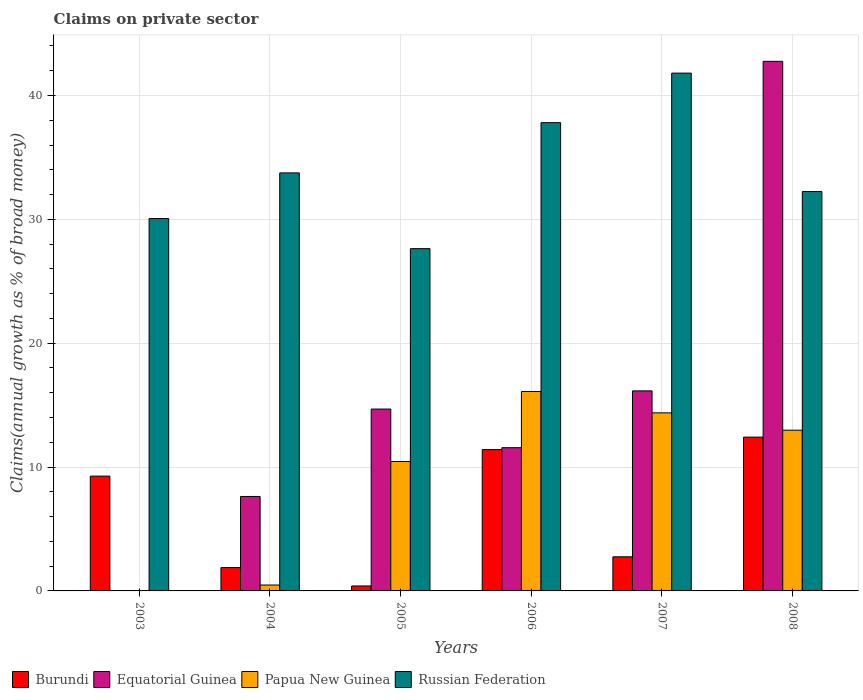How many different coloured bars are there?
Make the answer very short. 4. How many groups of bars are there?
Make the answer very short. 6. Are the number of bars on each tick of the X-axis equal?
Give a very brief answer. No. How many bars are there on the 2nd tick from the left?
Your answer should be very brief. 4. How many bars are there on the 6th tick from the right?
Your response must be concise. 2. What is the percentage of broad money claimed on private sector in Burundi in 2006?
Offer a very short reply. 11.41. Across all years, what is the maximum percentage of broad money claimed on private sector in Papua New Guinea?
Ensure brevity in your answer.  16.1. What is the total percentage of broad money claimed on private sector in Papua New Guinea in the graph?
Your response must be concise. 54.38. What is the difference between the percentage of broad money claimed on private sector in Equatorial Guinea in 2006 and that in 2008?
Keep it short and to the point. -31.19. What is the difference between the percentage of broad money claimed on private sector in Russian Federation in 2008 and the percentage of broad money claimed on private sector in Burundi in 2003?
Ensure brevity in your answer.  22.97. What is the average percentage of broad money claimed on private sector in Russian Federation per year?
Your response must be concise. 33.88. In the year 2007, what is the difference between the percentage of broad money claimed on private sector in Papua New Guinea and percentage of broad money claimed on private sector in Burundi?
Give a very brief answer. 11.62. What is the ratio of the percentage of broad money claimed on private sector in Russian Federation in 2006 to that in 2007?
Keep it short and to the point. 0.9. What is the difference between the highest and the second highest percentage of broad money claimed on private sector in Burundi?
Your answer should be compact. 1.01. What is the difference between the highest and the lowest percentage of broad money claimed on private sector in Papua New Guinea?
Your answer should be very brief. 16.1. In how many years, is the percentage of broad money claimed on private sector in Burundi greater than the average percentage of broad money claimed on private sector in Burundi taken over all years?
Your answer should be very brief. 3. Is it the case that in every year, the sum of the percentage of broad money claimed on private sector in Equatorial Guinea and percentage of broad money claimed on private sector in Papua New Guinea is greater than the percentage of broad money claimed on private sector in Burundi?
Give a very brief answer. No. How many bars are there?
Make the answer very short. 22. How many years are there in the graph?
Provide a succinct answer. 6. What is the difference between two consecutive major ticks on the Y-axis?
Make the answer very short. 10. Are the values on the major ticks of Y-axis written in scientific E-notation?
Provide a succinct answer. No. Does the graph contain any zero values?
Your answer should be very brief. Yes. Where does the legend appear in the graph?
Your response must be concise. Bottom left. How many legend labels are there?
Your answer should be compact. 4. How are the legend labels stacked?
Offer a terse response. Horizontal. What is the title of the graph?
Make the answer very short. Claims on private sector. What is the label or title of the Y-axis?
Offer a terse response. Claims(annual growth as % of broad money). What is the Claims(annual growth as % of broad money) of Burundi in 2003?
Provide a short and direct response. 9.27. What is the Claims(annual growth as % of broad money) of Equatorial Guinea in 2003?
Offer a terse response. 0. What is the Claims(annual growth as % of broad money) in Russian Federation in 2003?
Provide a succinct answer. 30.06. What is the Claims(annual growth as % of broad money) in Burundi in 2004?
Ensure brevity in your answer.  1.88. What is the Claims(annual growth as % of broad money) of Equatorial Guinea in 2004?
Your answer should be compact. 7.63. What is the Claims(annual growth as % of broad money) in Papua New Guinea in 2004?
Provide a short and direct response. 0.48. What is the Claims(annual growth as % of broad money) of Russian Federation in 2004?
Provide a succinct answer. 33.75. What is the Claims(annual growth as % of broad money) of Burundi in 2005?
Make the answer very short. 0.4. What is the Claims(annual growth as % of broad money) of Equatorial Guinea in 2005?
Your answer should be compact. 14.68. What is the Claims(annual growth as % of broad money) of Papua New Guinea in 2005?
Your response must be concise. 10.45. What is the Claims(annual growth as % of broad money) of Russian Federation in 2005?
Give a very brief answer. 27.63. What is the Claims(annual growth as % of broad money) of Burundi in 2006?
Provide a short and direct response. 11.41. What is the Claims(annual growth as % of broad money) of Equatorial Guinea in 2006?
Offer a terse response. 11.56. What is the Claims(annual growth as % of broad money) in Papua New Guinea in 2006?
Your answer should be very brief. 16.1. What is the Claims(annual growth as % of broad money) in Russian Federation in 2006?
Keep it short and to the point. 37.8. What is the Claims(annual growth as % of broad money) of Burundi in 2007?
Provide a short and direct response. 2.75. What is the Claims(annual growth as % of broad money) in Equatorial Guinea in 2007?
Keep it short and to the point. 16.15. What is the Claims(annual growth as % of broad money) of Papua New Guinea in 2007?
Make the answer very short. 14.38. What is the Claims(annual growth as % of broad money) of Russian Federation in 2007?
Your response must be concise. 41.8. What is the Claims(annual growth as % of broad money) in Burundi in 2008?
Provide a short and direct response. 12.42. What is the Claims(annual growth as % of broad money) in Equatorial Guinea in 2008?
Provide a short and direct response. 42.75. What is the Claims(annual growth as % of broad money) in Papua New Guinea in 2008?
Offer a terse response. 12.98. What is the Claims(annual growth as % of broad money) of Russian Federation in 2008?
Provide a short and direct response. 32.24. Across all years, what is the maximum Claims(annual growth as % of broad money) of Burundi?
Offer a terse response. 12.42. Across all years, what is the maximum Claims(annual growth as % of broad money) of Equatorial Guinea?
Make the answer very short. 42.75. Across all years, what is the maximum Claims(annual growth as % of broad money) of Papua New Guinea?
Your response must be concise. 16.1. Across all years, what is the maximum Claims(annual growth as % of broad money) of Russian Federation?
Keep it short and to the point. 41.8. Across all years, what is the minimum Claims(annual growth as % of broad money) in Burundi?
Provide a short and direct response. 0.4. Across all years, what is the minimum Claims(annual growth as % of broad money) of Equatorial Guinea?
Your response must be concise. 0. Across all years, what is the minimum Claims(annual growth as % of broad money) in Russian Federation?
Keep it short and to the point. 27.63. What is the total Claims(annual growth as % of broad money) in Burundi in the graph?
Your response must be concise. 38.13. What is the total Claims(annual growth as % of broad money) of Equatorial Guinea in the graph?
Your response must be concise. 92.78. What is the total Claims(annual growth as % of broad money) in Papua New Guinea in the graph?
Your answer should be very brief. 54.38. What is the total Claims(annual growth as % of broad money) in Russian Federation in the graph?
Provide a succinct answer. 203.29. What is the difference between the Claims(annual growth as % of broad money) of Burundi in 2003 and that in 2004?
Your response must be concise. 7.38. What is the difference between the Claims(annual growth as % of broad money) in Russian Federation in 2003 and that in 2004?
Your response must be concise. -3.69. What is the difference between the Claims(annual growth as % of broad money) in Burundi in 2003 and that in 2005?
Offer a very short reply. 8.87. What is the difference between the Claims(annual growth as % of broad money) of Russian Federation in 2003 and that in 2005?
Offer a terse response. 2.43. What is the difference between the Claims(annual growth as % of broad money) of Burundi in 2003 and that in 2006?
Ensure brevity in your answer.  -2.14. What is the difference between the Claims(annual growth as % of broad money) in Russian Federation in 2003 and that in 2006?
Your answer should be very brief. -7.74. What is the difference between the Claims(annual growth as % of broad money) in Burundi in 2003 and that in 2007?
Make the answer very short. 6.51. What is the difference between the Claims(annual growth as % of broad money) in Russian Federation in 2003 and that in 2007?
Offer a very short reply. -11.74. What is the difference between the Claims(annual growth as % of broad money) in Burundi in 2003 and that in 2008?
Your answer should be compact. -3.15. What is the difference between the Claims(annual growth as % of broad money) of Russian Federation in 2003 and that in 2008?
Your answer should be very brief. -2.18. What is the difference between the Claims(annual growth as % of broad money) of Burundi in 2004 and that in 2005?
Your answer should be very brief. 1.48. What is the difference between the Claims(annual growth as % of broad money) in Equatorial Guinea in 2004 and that in 2005?
Keep it short and to the point. -7.06. What is the difference between the Claims(annual growth as % of broad money) of Papua New Guinea in 2004 and that in 2005?
Keep it short and to the point. -9.98. What is the difference between the Claims(annual growth as % of broad money) in Russian Federation in 2004 and that in 2005?
Your response must be concise. 6.12. What is the difference between the Claims(annual growth as % of broad money) of Burundi in 2004 and that in 2006?
Ensure brevity in your answer.  -9.52. What is the difference between the Claims(annual growth as % of broad money) in Equatorial Guinea in 2004 and that in 2006?
Offer a very short reply. -3.94. What is the difference between the Claims(annual growth as % of broad money) of Papua New Guinea in 2004 and that in 2006?
Give a very brief answer. -15.62. What is the difference between the Claims(annual growth as % of broad money) in Russian Federation in 2004 and that in 2006?
Keep it short and to the point. -4.06. What is the difference between the Claims(annual growth as % of broad money) in Burundi in 2004 and that in 2007?
Give a very brief answer. -0.87. What is the difference between the Claims(annual growth as % of broad money) in Equatorial Guinea in 2004 and that in 2007?
Keep it short and to the point. -8.52. What is the difference between the Claims(annual growth as % of broad money) of Papua New Guinea in 2004 and that in 2007?
Provide a short and direct response. -13.9. What is the difference between the Claims(annual growth as % of broad money) of Russian Federation in 2004 and that in 2007?
Ensure brevity in your answer.  -8.06. What is the difference between the Claims(annual growth as % of broad money) of Burundi in 2004 and that in 2008?
Offer a terse response. -10.53. What is the difference between the Claims(annual growth as % of broad money) in Equatorial Guinea in 2004 and that in 2008?
Keep it short and to the point. -35.13. What is the difference between the Claims(annual growth as % of broad money) of Papua New Guinea in 2004 and that in 2008?
Your answer should be compact. -12.5. What is the difference between the Claims(annual growth as % of broad money) of Russian Federation in 2004 and that in 2008?
Provide a succinct answer. 1.51. What is the difference between the Claims(annual growth as % of broad money) in Burundi in 2005 and that in 2006?
Ensure brevity in your answer.  -11.01. What is the difference between the Claims(annual growth as % of broad money) in Equatorial Guinea in 2005 and that in 2006?
Provide a succinct answer. 3.12. What is the difference between the Claims(annual growth as % of broad money) in Papua New Guinea in 2005 and that in 2006?
Your response must be concise. -5.65. What is the difference between the Claims(annual growth as % of broad money) of Russian Federation in 2005 and that in 2006?
Provide a short and direct response. -10.17. What is the difference between the Claims(annual growth as % of broad money) of Burundi in 2005 and that in 2007?
Make the answer very short. -2.35. What is the difference between the Claims(annual growth as % of broad money) in Equatorial Guinea in 2005 and that in 2007?
Your answer should be compact. -1.47. What is the difference between the Claims(annual growth as % of broad money) of Papua New Guinea in 2005 and that in 2007?
Give a very brief answer. -3.93. What is the difference between the Claims(annual growth as % of broad money) in Russian Federation in 2005 and that in 2007?
Your answer should be compact. -14.17. What is the difference between the Claims(annual growth as % of broad money) of Burundi in 2005 and that in 2008?
Give a very brief answer. -12.02. What is the difference between the Claims(annual growth as % of broad money) of Equatorial Guinea in 2005 and that in 2008?
Your response must be concise. -28.07. What is the difference between the Claims(annual growth as % of broad money) of Papua New Guinea in 2005 and that in 2008?
Provide a succinct answer. -2.53. What is the difference between the Claims(annual growth as % of broad money) of Russian Federation in 2005 and that in 2008?
Provide a short and direct response. -4.61. What is the difference between the Claims(annual growth as % of broad money) of Burundi in 2006 and that in 2007?
Offer a terse response. 8.65. What is the difference between the Claims(annual growth as % of broad money) in Equatorial Guinea in 2006 and that in 2007?
Offer a terse response. -4.59. What is the difference between the Claims(annual growth as % of broad money) of Papua New Guinea in 2006 and that in 2007?
Your response must be concise. 1.72. What is the difference between the Claims(annual growth as % of broad money) in Russian Federation in 2006 and that in 2007?
Your response must be concise. -4. What is the difference between the Claims(annual growth as % of broad money) of Burundi in 2006 and that in 2008?
Ensure brevity in your answer.  -1.01. What is the difference between the Claims(annual growth as % of broad money) of Equatorial Guinea in 2006 and that in 2008?
Offer a very short reply. -31.19. What is the difference between the Claims(annual growth as % of broad money) in Papua New Guinea in 2006 and that in 2008?
Provide a short and direct response. 3.12. What is the difference between the Claims(annual growth as % of broad money) in Russian Federation in 2006 and that in 2008?
Provide a succinct answer. 5.56. What is the difference between the Claims(annual growth as % of broad money) in Burundi in 2007 and that in 2008?
Your answer should be very brief. -9.66. What is the difference between the Claims(annual growth as % of broad money) in Equatorial Guinea in 2007 and that in 2008?
Your response must be concise. -26.6. What is the difference between the Claims(annual growth as % of broad money) in Papua New Guinea in 2007 and that in 2008?
Make the answer very short. 1.4. What is the difference between the Claims(annual growth as % of broad money) in Russian Federation in 2007 and that in 2008?
Your response must be concise. 9.56. What is the difference between the Claims(annual growth as % of broad money) in Burundi in 2003 and the Claims(annual growth as % of broad money) in Equatorial Guinea in 2004?
Ensure brevity in your answer.  1.64. What is the difference between the Claims(annual growth as % of broad money) of Burundi in 2003 and the Claims(annual growth as % of broad money) of Papua New Guinea in 2004?
Offer a very short reply. 8.79. What is the difference between the Claims(annual growth as % of broad money) of Burundi in 2003 and the Claims(annual growth as % of broad money) of Russian Federation in 2004?
Provide a short and direct response. -24.48. What is the difference between the Claims(annual growth as % of broad money) of Burundi in 2003 and the Claims(annual growth as % of broad money) of Equatorial Guinea in 2005?
Ensure brevity in your answer.  -5.41. What is the difference between the Claims(annual growth as % of broad money) of Burundi in 2003 and the Claims(annual growth as % of broad money) of Papua New Guinea in 2005?
Provide a short and direct response. -1.18. What is the difference between the Claims(annual growth as % of broad money) in Burundi in 2003 and the Claims(annual growth as % of broad money) in Russian Federation in 2005?
Offer a terse response. -18.36. What is the difference between the Claims(annual growth as % of broad money) in Burundi in 2003 and the Claims(annual growth as % of broad money) in Equatorial Guinea in 2006?
Offer a very short reply. -2.3. What is the difference between the Claims(annual growth as % of broad money) of Burundi in 2003 and the Claims(annual growth as % of broad money) of Papua New Guinea in 2006?
Provide a short and direct response. -6.83. What is the difference between the Claims(annual growth as % of broad money) in Burundi in 2003 and the Claims(annual growth as % of broad money) in Russian Federation in 2006?
Ensure brevity in your answer.  -28.54. What is the difference between the Claims(annual growth as % of broad money) of Burundi in 2003 and the Claims(annual growth as % of broad money) of Equatorial Guinea in 2007?
Make the answer very short. -6.88. What is the difference between the Claims(annual growth as % of broad money) in Burundi in 2003 and the Claims(annual growth as % of broad money) in Papua New Guinea in 2007?
Your answer should be compact. -5.11. What is the difference between the Claims(annual growth as % of broad money) in Burundi in 2003 and the Claims(annual growth as % of broad money) in Russian Federation in 2007?
Make the answer very short. -32.54. What is the difference between the Claims(annual growth as % of broad money) of Burundi in 2003 and the Claims(annual growth as % of broad money) of Equatorial Guinea in 2008?
Keep it short and to the point. -33.49. What is the difference between the Claims(annual growth as % of broad money) in Burundi in 2003 and the Claims(annual growth as % of broad money) in Papua New Guinea in 2008?
Provide a succinct answer. -3.71. What is the difference between the Claims(annual growth as % of broad money) in Burundi in 2003 and the Claims(annual growth as % of broad money) in Russian Federation in 2008?
Keep it short and to the point. -22.97. What is the difference between the Claims(annual growth as % of broad money) of Burundi in 2004 and the Claims(annual growth as % of broad money) of Equatorial Guinea in 2005?
Offer a very short reply. -12.8. What is the difference between the Claims(annual growth as % of broad money) of Burundi in 2004 and the Claims(annual growth as % of broad money) of Papua New Guinea in 2005?
Offer a very short reply. -8.57. What is the difference between the Claims(annual growth as % of broad money) in Burundi in 2004 and the Claims(annual growth as % of broad money) in Russian Federation in 2005?
Make the answer very short. -25.75. What is the difference between the Claims(annual growth as % of broad money) of Equatorial Guinea in 2004 and the Claims(annual growth as % of broad money) of Papua New Guinea in 2005?
Offer a terse response. -2.82. What is the difference between the Claims(annual growth as % of broad money) in Equatorial Guinea in 2004 and the Claims(annual growth as % of broad money) in Russian Federation in 2005?
Your response must be concise. -20.01. What is the difference between the Claims(annual growth as % of broad money) of Papua New Guinea in 2004 and the Claims(annual growth as % of broad money) of Russian Federation in 2005?
Ensure brevity in your answer.  -27.16. What is the difference between the Claims(annual growth as % of broad money) in Burundi in 2004 and the Claims(annual growth as % of broad money) in Equatorial Guinea in 2006?
Provide a succinct answer. -9.68. What is the difference between the Claims(annual growth as % of broad money) in Burundi in 2004 and the Claims(annual growth as % of broad money) in Papua New Guinea in 2006?
Give a very brief answer. -14.22. What is the difference between the Claims(annual growth as % of broad money) of Burundi in 2004 and the Claims(annual growth as % of broad money) of Russian Federation in 2006?
Provide a succinct answer. -35.92. What is the difference between the Claims(annual growth as % of broad money) in Equatorial Guinea in 2004 and the Claims(annual growth as % of broad money) in Papua New Guinea in 2006?
Provide a succinct answer. -8.47. What is the difference between the Claims(annual growth as % of broad money) in Equatorial Guinea in 2004 and the Claims(annual growth as % of broad money) in Russian Federation in 2006?
Provide a succinct answer. -30.18. What is the difference between the Claims(annual growth as % of broad money) in Papua New Guinea in 2004 and the Claims(annual growth as % of broad money) in Russian Federation in 2006?
Keep it short and to the point. -37.33. What is the difference between the Claims(annual growth as % of broad money) in Burundi in 2004 and the Claims(annual growth as % of broad money) in Equatorial Guinea in 2007?
Give a very brief answer. -14.27. What is the difference between the Claims(annual growth as % of broad money) in Burundi in 2004 and the Claims(annual growth as % of broad money) in Papua New Guinea in 2007?
Make the answer very short. -12.49. What is the difference between the Claims(annual growth as % of broad money) in Burundi in 2004 and the Claims(annual growth as % of broad money) in Russian Federation in 2007?
Provide a succinct answer. -39.92. What is the difference between the Claims(annual growth as % of broad money) in Equatorial Guinea in 2004 and the Claims(annual growth as % of broad money) in Papua New Guinea in 2007?
Give a very brief answer. -6.75. What is the difference between the Claims(annual growth as % of broad money) of Equatorial Guinea in 2004 and the Claims(annual growth as % of broad money) of Russian Federation in 2007?
Offer a very short reply. -34.18. What is the difference between the Claims(annual growth as % of broad money) in Papua New Guinea in 2004 and the Claims(annual growth as % of broad money) in Russian Federation in 2007?
Ensure brevity in your answer.  -41.33. What is the difference between the Claims(annual growth as % of broad money) of Burundi in 2004 and the Claims(annual growth as % of broad money) of Equatorial Guinea in 2008?
Provide a succinct answer. -40.87. What is the difference between the Claims(annual growth as % of broad money) in Burundi in 2004 and the Claims(annual growth as % of broad money) in Papua New Guinea in 2008?
Offer a very short reply. -11.09. What is the difference between the Claims(annual growth as % of broad money) in Burundi in 2004 and the Claims(annual growth as % of broad money) in Russian Federation in 2008?
Ensure brevity in your answer.  -30.36. What is the difference between the Claims(annual growth as % of broad money) in Equatorial Guinea in 2004 and the Claims(annual growth as % of broad money) in Papua New Guinea in 2008?
Offer a terse response. -5.35. What is the difference between the Claims(annual growth as % of broad money) in Equatorial Guinea in 2004 and the Claims(annual growth as % of broad money) in Russian Federation in 2008?
Give a very brief answer. -24.62. What is the difference between the Claims(annual growth as % of broad money) in Papua New Guinea in 2004 and the Claims(annual growth as % of broad money) in Russian Federation in 2008?
Make the answer very short. -31.77. What is the difference between the Claims(annual growth as % of broad money) of Burundi in 2005 and the Claims(annual growth as % of broad money) of Equatorial Guinea in 2006?
Your answer should be compact. -11.16. What is the difference between the Claims(annual growth as % of broad money) in Burundi in 2005 and the Claims(annual growth as % of broad money) in Papua New Guinea in 2006?
Keep it short and to the point. -15.7. What is the difference between the Claims(annual growth as % of broad money) in Burundi in 2005 and the Claims(annual growth as % of broad money) in Russian Federation in 2006?
Make the answer very short. -37.4. What is the difference between the Claims(annual growth as % of broad money) in Equatorial Guinea in 2005 and the Claims(annual growth as % of broad money) in Papua New Guinea in 2006?
Your answer should be very brief. -1.42. What is the difference between the Claims(annual growth as % of broad money) of Equatorial Guinea in 2005 and the Claims(annual growth as % of broad money) of Russian Federation in 2006?
Your response must be concise. -23.12. What is the difference between the Claims(annual growth as % of broad money) of Papua New Guinea in 2005 and the Claims(annual growth as % of broad money) of Russian Federation in 2006?
Offer a terse response. -27.35. What is the difference between the Claims(annual growth as % of broad money) of Burundi in 2005 and the Claims(annual growth as % of broad money) of Equatorial Guinea in 2007?
Provide a short and direct response. -15.75. What is the difference between the Claims(annual growth as % of broad money) of Burundi in 2005 and the Claims(annual growth as % of broad money) of Papua New Guinea in 2007?
Keep it short and to the point. -13.98. What is the difference between the Claims(annual growth as % of broad money) in Burundi in 2005 and the Claims(annual growth as % of broad money) in Russian Federation in 2007?
Ensure brevity in your answer.  -41.4. What is the difference between the Claims(annual growth as % of broad money) of Equatorial Guinea in 2005 and the Claims(annual growth as % of broad money) of Papua New Guinea in 2007?
Your answer should be compact. 0.3. What is the difference between the Claims(annual growth as % of broad money) in Equatorial Guinea in 2005 and the Claims(annual growth as % of broad money) in Russian Federation in 2007?
Offer a terse response. -27.12. What is the difference between the Claims(annual growth as % of broad money) in Papua New Guinea in 2005 and the Claims(annual growth as % of broad money) in Russian Federation in 2007?
Your answer should be compact. -31.35. What is the difference between the Claims(annual growth as % of broad money) of Burundi in 2005 and the Claims(annual growth as % of broad money) of Equatorial Guinea in 2008?
Make the answer very short. -42.35. What is the difference between the Claims(annual growth as % of broad money) of Burundi in 2005 and the Claims(annual growth as % of broad money) of Papua New Guinea in 2008?
Your response must be concise. -12.58. What is the difference between the Claims(annual growth as % of broad money) in Burundi in 2005 and the Claims(annual growth as % of broad money) in Russian Federation in 2008?
Provide a succinct answer. -31.84. What is the difference between the Claims(annual growth as % of broad money) in Equatorial Guinea in 2005 and the Claims(annual growth as % of broad money) in Papua New Guinea in 2008?
Ensure brevity in your answer.  1.71. What is the difference between the Claims(annual growth as % of broad money) in Equatorial Guinea in 2005 and the Claims(annual growth as % of broad money) in Russian Federation in 2008?
Give a very brief answer. -17.56. What is the difference between the Claims(annual growth as % of broad money) in Papua New Guinea in 2005 and the Claims(annual growth as % of broad money) in Russian Federation in 2008?
Your response must be concise. -21.79. What is the difference between the Claims(annual growth as % of broad money) of Burundi in 2006 and the Claims(annual growth as % of broad money) of Equatorial Guinea in 2007?
Make the answer very short. -4.74. What is the difference between the Claims(annual growth as % of broad money) in Burundi in 2006 and the Claims(annual growth as % of broad money) in Papua New Guinea in 2007?
Your response must be concise. -2.97. What is the difference between the Claims(annual growth as % of broad money) in Burundi in 2006 and the Claims(annual growth as % of broad money) in Russian Federation in 2007?
Your response must be concise. -30.4. What is the difference between the Claims(annual growth as % of broad money) in Equatorial Guinea in 2006 and the Claims(annual growth as % of broad money) in Papua New Guinea in 2007?
Make the answer very short. -2.81. What is the difference between the Claims(annual growth as % of broad money) in Equatorial Guinea in 2006 and the Claims(annual growth as % of broad money) in Russian Federation in 2007?
Your answer should be compact. -30.24. What is the difference between the Claims(annual growth as % of broad money) in Papua New Guinea in 2006 and the Claims(annual growth as % of broad money) in Russian Federation in 2007?
Ensure brevity in your answer.  -25.7. What is the difference between the Claims(annual growth as % of broad money) in Burundi in 2006 and the Claims(annual growth as % of broad money) in Equatorial Guinea in 2008?
Give a very brief answer. -31.35. What is the difference between the Claims(annual growth as % of broad money) in Burundi in 2006 and the Claims(annual growth as % of broad money) in Papua New Guinea in 2008?
Your answer should be compact. -1.57. What is the difference between the Claims(annual growth as % of broad money) in Burundi in 2006 and the Claims(annual growth as % of broad money) in Russian Federation in 2008?
Provide a succinct answer. -20.83. What is the difference between the Claims(annual growth as % of broad money) in Equatorial Guinea in 2006 and the Claims(annual growth as % of broad money) in Papua New Guinea in 2008?
Provide a succinct answer. -1.41. What is the difference between the Claims(annual growth as % of broad money) in Equatorial Guinea in 2006 and the Claims(annual growth as % of broad money) in Russian Federation in 2008?
Offer a terse response. -20.68. What is the difference between the Claims(annual growth as % of broad money) of Papua New Guinea in 2006 and the Claims(annual growth as % of broad money) of Russian Federation in 2008?
Keep it short and to the point. -16.14. What is the difference between the Claims(annual growth as % of broad money) of Burundi in 2007 and the Claims(annual growth as % of broad money) of Equatorial Guinea in 2008?
Give a very brief answer. -40. What is the difference between the Claims(annual growth as % of broad money) in Burundi in 2007 and the Claims(annual growth as % of broad money) in Papua New Guinea in 2008?
Offer a terse response. -10.22. What is the difference between the Claims(annual growth as % of broad money) of Burundi in 2007 and the Claims(annual growth as % of broad money) of Russian Federation in 2008?
Offer a terse response. -29.49. What is the difference between the Claims(annual growth as % of broad money) of Equatorial Guinea in 2007 and the Claims(annual growth as % of broad money) of Papua New Guinea in 2008?
Your answer should be compact. 3.17. What is the difference between the Claims(annual growth as % of broad money) of Equatorial Guinea in 2007 and the Claims(annual growth as % of broad money) of Russian Federation in 2008?
Make the answer very short. -16.09. What is the difference between the Claims(annual growth as % of broad money) in Papua New Guinea in 2007 and the Claims(annual growth as % of broad money) in Russian Federation in 2008?
Your answer should be compact. -17.86. What is the average Claims(annual growth as % of broad money) of Burundi per year?
Make the answer very short. 6.36. What is the average Claims(annual growth as % of broad money) of Equatorial Guinea per year?
Make the answer very short. 15.46. What is the average Claims(annual growth as % of broad money) in Papua New Guinea per year?
Your answer should be very brief. 9.06. What is the average Claims(annual growth as % of broad money) of Russian Federation per year?
Provide a succinct answer. 33.88. In the year 2003, what is the difference between the Claims(annual growth as % of broad money) of Burundi and Claims(annual growth as % of broad money) of Russian Federation?
Your answer should be compact. -20.79. In the year 2004, what is the difference between the Claims(annual growth as % of broad money) in Burundi and Claims(annual growth as % of broad money) in Equatorial Guinea?
Offer a very short reply. -5.74. In the year 2004, what is the difference between the Claims(annual growth as % of broad money) in Burundi and Claims(annual growth as % of broad money) in Papua New Guinea?
Your answer should be very brief. 1.41. In the year 2004, what is the difference between the Claims(annual growth as % of broad money) of Burundi and Claims(annual growth as % of broad money) of Russian Federation?
Give a very brief answer. -31.86. In the year 2004, what is the difference between the Claims(annual growth as % of broad money) of Equatorial Guinea and Claims(annual growth as % of broad money) of Papua New Guinea?
Keep it short and to the point. 7.15. In the year 2004, what is the difference between the Claims(annual growth as % of broad money) in Equatorial Guinea and Claims(annual growth as % of broad money) in Russian Federation?
Your answer should be compact. -26.12. In the year 2004, what is the difference between the Claims(annual growth as % of broad money) in Papua New Guinea and Claims(annual growth as % of broad money) in Russian Federation?
Offer a very short reply. -33.27. In the year 2005, what is the difference between the Claims(annual growth as % of broad money) of Burundi and Claims(annual growth as % of broad money) of Equatorial Guinea?
Keep it short and to the point. -14.28. In the year 2005, what is the difference between the Claims(annual growth as % of broad money) in Burundi and Claims(annual growth as % of broad money) in Papua New Guinea?
Ensure brevity in your answer.  -10.05. In the year 2005, what is the difference between the Claims(annual growth as % of broad money) of Burundi and Claims(annual growth as % of broad money) of Russian Federation?
Give a very brief answer. -27.23. In the year 2005, what is the difference between the Claims(annual growth as % of broad money) in Equatorial Guinea and Claims(annual growth as % of broad money) in Papua New Guinea?
Give a very brief answer. 4.23. In the year 2005, what is the difference between the Claims(annual growth as % of broad money) in Equatorial Guinea and Claims(annual growth as % of broad money) in Russian Federation?
Your answer should be compact. -12.95. In the year 2005, what is the difference between the Claims(annual growth as % of broad money) in Papua New Guinea and Claims(annual growth as % of broad money) in Russian Federation?
Ensure brevity in your answer.  -17.18. In the year 2006, what is the difference between the Claims(annual growth as % of broad money) in Burundi and Claims(annual growth as % of broad money) in Equatorial Guinea?
Provide a short and direct response. -0.16. In the year 2006, what is the difference between the Claims(annual growth as % of broad money) in Burundi and Claims(annual growth as % of broad money) in Papua New Guinea?
Give a very brief answer. -4.69. In the year 2006, what is the difference between the Claims(annual growth as % of broad money) of Burundi and Claims(annual growth as % of broad money) of Russian Federation?
Your response must be concise. -26.4. In the year 2006, what is the difference between the Claims(annual growth as % of broad money) of Equatorial Guinea and Claims(annual growth as % of broad money) of Papua New Guinea?
Give a very brief answer. -4.54. In the year 2006, what is the difference between the Claims(annual growth as % of broad money) of Equatorial Guinea and Claims(annual growth as % of broad money) of Russian Federation?
Keep it short and to the point. -26.24. In the year 2006, what is the difference between the Claims(annual growth as % of broad money) in Papua New Guinea and Claims(annual growth as % of broad money) in Russian Federation?
Ensure brevity in your answer.  -21.7. In the year 2007, what is the difference between the Claims(annual growth as % of broad money) in Burundi and Claims(annual growth as % of broad money) in Equatorial Guinea?
Your answer should be very brief. -13.4. In the year 2007, what is the difference between the Claims(annual growth as % of broad money) in Burundi and Claims(annual growth as % of broad money) in Papua New Guinea?
Make the answer very short. -11.62. In the year 2007, what is the difference between the Claims(annual growth as % of broad money) of Burundi and Claims(annual growth as % of broad money) of Russian Federation?
Make the answer very short. -39.05. In the year 2007, what is the difference between the Claims(annual growth as % of broad money) of Equatorial Guinea and Claims(annual growth as % of broad money) of Papua New Guinea?
Provide a short and direct response. 1.77. In the year 2007, what is the difference between the Claims(annual growth as % of broad money) of Equatorial Guinea and Claims(annual growth as % of broad money) of Russian Federation?
Your response must be concise. -25.65. In the year 2007, what is the difference between the Claims(annual growth as % of broad money) of Papua New Guinea and Claims(annual growth as % of broad money) of Russian Federation?
Keep it short and to the point. -27.43. In the year 2008, what is the difference between the Claims(annual growth as % of broad money) of Burundi and Claims(annual growth as % of broad money) of Equatorial Guinea?
Your answer should be compact. -30.34. In the year 2008, what is the difference between the Claims(annual growth as % of broad money) of Burundi and Claims(annual growth as % of broad money) of Papua New Guinea?
Your answer should be compact. -0.56. In the year 2008, what is the difference between the Claims(annual growth as % of broad money) of Burundi and Claims(annual growth as % of broad money) of Russian Federation?
Provide a succinct answer. -19.83. In the year 2008, what is the difference between the Claims(annual growth as % of broad money) of Equatorial Guinea and Claims(annual growth as % of broad money) of Papua New Guinea?
Provide a succinct answer. 29.78. In the year 2008, what is the difference between the Claims(annual growth as % of broad money) of Equatorial Guinea and Claims(annual growth as % of broad money) of Russian Federation?
Provide a short and direct response. 10.51. In the year 2008, what is the difference between the Claims(annual growth as % of broad money) in Papua New Guinea and Claims(annual growth as % of broad money) in Russian Federation?
Offer a terse response. -19.27. What is the ratio of the Claims(annual growth as % of broad money) in Burundi in 2003 to that in 2004?
Make the answer very short. 4.92. What is the ratio of the Claims(annual growth as % of broad money) in Russian Federation in 2003 to that in 2004?
Give a very brief answer. 0.89. What is the ratio of the Claims(annual growth as % of broad money) in Burundi in 2003 to that in 2005?
Offer a terse response. 23.12. What is the ratio of the Claims(annual growth as % of broad money) in Russian Federation in 2003 to that in 2005?
Keep it short and to the point. 1.09. What is the ratio of the Claims(annual growth as % of broad money) in Burundi in 2003 to that in 2006?
Ensure brevity in your answer.  0.81. What is the ratio of the Claims(annual growth as % of broad money) of Russian Federation in 2003 to that in 2006?
Keep it short and to the point. 0.8. What is the ratio of the Claims(annual growth as % of broad money) in Burundi in 2003 to that in 2007?
Give a very brief answer. 3.36. What is the ratio of the Claims(annual growth as % of broad money) in Russian Federation in 2003 to that in 2007?
Make the answer very short. 0.72. What is the ratio of the Claims(annual growth as % of broad money) in Burundi in 2003 to that in 2008?
Offer a very short reply. 0.75. What is the ratio of the Claims(annual growth as % of broad money) in Russian Federation in 2003 to that in 2008?
Ensure brevity in your answer.  0.93. What is the ratio of the Claims(annual growth as % of broad money) of Burundi in 2004 to that in 2005?
Ensure brevity in your answer.  4.7. What is the ratio of the Claims(annual growth as % of broad money) in Equatorial Guinea in 2004 to that in 2005?
Your answer should be very brief. 0.52. What is the ratio of the Claims(annual growth as % of broad money) in Papua New Guinea in 2004 to that in 2005?
Keep it short and to the point. 0.05. What is the ratio of the Claims(annual growth as % of broad money) of Russian Federation in 2004 to that in 2005?
Keep it short and to the point. 1.22. What is the ratio of the Claims(annual growth as % of broad money) in Burundi in 2004 to that in 2006?
Your answer should be compact. 0.17. What is the ratio of the Claims(annual growth as % of broad money) in Equatorial Guinea in 2004 to that in 2006?
Your response must be concise. 0.66. What is the ratio of the Claims(annual growth as % of broad money) in Papua New Guinea in 2004 to that in 2006?
Offer a terse response. 0.03. What is the ratio of the Claims(annual growth as % of broad money) of Russian Federation in 2004 to that in 2006?
Provide a succinct answer. 0.89. What is the ratio of the Claims(annual growth as % of broad money) in Burundi in 2004 to that in 2007?
Your response must be concise. 0.68. What is the ratio of the Claims(annual growth as % of broad money) of Equatorial Guinea in 2004 to that in 2007?
Your answer should be very brief. 0.47. What is the ratio of the Claims(annual growth as % of broad money) of Papua New Guinea in 2004 to that in 2007?
Keep it short and to the point. 0.03. What is the ratio of the Claims(annual growth as % of broad money) in Russian Federation in 2004 to that in 2007?
Your response must be concise. 0.81. What is the ratio of the Claims(annual growth as % of broad money) of Burundi in 2004 to that in 2008?
Provide a succinct answer. 0.15. What is the ratio of the Claims(annual growth as % of broad money) of Equatorial Guinea in 2004 to that in 2008?
Provide a succinct answer. 0.18. What is the ratio of the Claims(annual growth as % of broad money) of Papua New Guinea in 2004 to that in 2008?
Provide a succinct answer. 0.04. What is the ratio of the Claims(annual growth as % of broad money) in Russian Federation in 2004 to that in 2008?
Give a very brief answer. 1.05. What is the ratio of the Claims(annual growth as % of broad money) in Burundi in 2005 to that in 2006?
Your response must be concise. 0.04. What is the ratio of the Claims(annual growth as % of broad money) in Equatorial Guinea in 2005 to that in 2006?
Keep it short and to the point. 1.27. What is the ratio of the Claims(annual growth as % of broad money) of Papua New Guinea in 2005 to that in 2006?
Your answer should be very brief. 0.65. What is the ratio of the Claims(annual growth as % of broad money) in Russian Federation in 2005 to that in 2006?
Provide a short and direct response. 0.73. What is the ratio of the Claims(annual growth as % of broad money) in Burundi in 2005 to that in 2007?
Keep it short and to the point. 0.15. What is the ratio of the Claims(annual growth as % of broad money) in Equatorial Guinea in 2005 to that in 2007?
Offer a terse response. 0.91. What is the ratio of the Claims(annual growth as % of broad money) of Papua New Guinea in 2005 to that in 2007?
Provide a succinct answer. 0.73. What is the ratio of the Claims(annual growth as % of broad money) of Russian Federation in 2005 to that in 2007?
Give a very brief answer. 0.66. What is the ratio of the Claims(annual growth as % of broad money) in Burundi in 2005 to that in 2008?
Ensure brevity in your answer.  0.03. What is the ratio of the Claims(annual growth as % of broad money) of Equatorial Guinea in 2005 to that in 2008?
Your answer should be very brief. 0.34. What is the ratio of the Claims(annual growth as % of broad money) of Papua New Guinea in 2005 to that in 2008?
Your response must be concise. 0.81. What is the ratio of the Claims(annual growth as % of broad money) in Russian Federation in 2005 to that in 2008?
Ensure brevity in your answer.  0.86. What is the ratio of the Claims(annual growth as % of broad money) of Burundi in 2006 to that in 2007?
Keep it short and to the point. 4.14. What is the ratio of the Claims(annual growth as % of broad money) in Equatorial Guinea in 2006 to that in 2007?
Offer a terse response. 0.72. What is the ratio of the Claims(annual growth as % of broad money) in Papua New Guinea in 2006 to that in 2007?
Give a very brief answer. 1.12. What is the ratio of the Claims(annual growth as % of broad money) in Russian Federation in 2006 to that in 2007?
Keep it short and to the point. 0.9. What is the ratio of the Claims(annual growth as % of broad money) of Burundi in 2006 to that in 2008?
Keep it short and to the point. 0.92. What is the ratio of the Claims(annual growth as % of broad money) in Equatorial Guinea in 2006 to that in 2008?
Give a very brief answer. 0.27. What is the ratio of the Claims(annual growth as % of broad money) in Papua New Guinea in 2006 to that in 2008?
Provide a short and direct response. 1.24. What is the ratio of the Claims(annual growth as % of broad money) in Russian Federation in 2006 to that in 2008?
Keep it short and to the point. 1.17. What is the ratio of the Claims(annual growth as % of broad money) of Burundi in 2007 to that in 2008?
Your answer should be very brief. 0.22. What is the ratio of the Claims(annual growth as % of broad money) in Equatorial Guinea in 2007 to that in 2008?
Ensure brevity in your answer.  0.38. What is the ratio of the Claims(annual growth as % of broad money) of Papua New Guinea in 2007 to that in 2008?
Offer a terse response. 1.11. What is the ratio of the Claims(annual growth as % of broad money) of Russian Federation in 2007 to that in 2008?
Offer a terse response. 1.3. What is the difference between the highest and the second highest Claims(annual growth as % of broad money) in Burundi?
Your response must be concise. 1.01. What is the difference between the highest and the second highest Claims(annual growth as % of broad money) in Equatorial Guinea?
Offer a very short reply. 26.6. What is the difference between the highest and the second highest Claims(annual growth as % of broad money) of Papua New Guinea?
Make the answer very short. 1.72. What is the difference between the highest and the second highest Claims(annual growth as % of broad money) of Russian Federation?
Your response must be concise. 4. What is the difference between the highest and the lowest Claims(annual growth as % of broad money) in Burundi?
Make the answer very short. 12.02. What is the difference between the highest and the lowest Claims(annual growth as % of broad money) of Equatorial Guinea?
Provide a succinct answer. 42.75. What is the difference between the highest and the lowest Claims(annual growth as % of broad money) in Papua New Guinea?
Make the answer very short. 16.1. What is the difference between the highest and the lowest Claims(annual growth as % of broad money) in Russian Federation?
Your answer should be very brief. 14.17. 